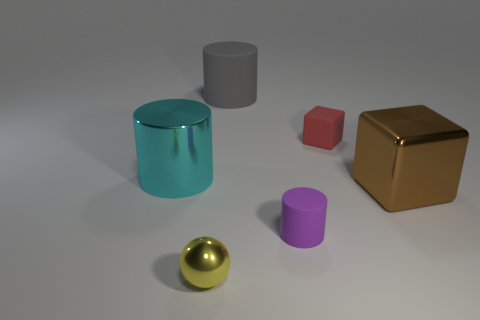What is the shape of the purple matte object?
Offer a very short reply. Cylinder. There is a big cylinder that is the same material as the sphere; what color is it?
Provide a short and direct response. Cyan. Is the number of red matte things greater than the number of tiny cyan shiny things?
Give a very brief answer. Yes. Is there a yellow shiny ball?
Your answer should be compact. Yes. What shape is the small rubber object behind the big metallic thing on the right side of the small metallic thing?
Your response must be concise. Cube. How many objects are either tiny red rubber things or things that are in front of the tiny red block?
Your answer should be very brief. 5. There is a large object that is in front of the cylinder left of the gray matte cylinder that is on the left side of the small block; what is its color?
Keep it short and to the point. Brown. There is another large object that is the same shape as the red rubber object; what material is it?
Your answer should be compact. Metal. What is the color of the big metallic cylinder?
Make the answer very short. Cyan. Is the color of the shiny block the same as the tiny metal thing?
Provide a short and direct response. No. 